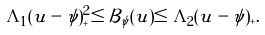Convert formula to latex. <formula><loc_0><loc_0><loc_500><loc_500>\Lambda _ { 1 } ( u - \psi ) _ { + } ^ { 2 } \leq \mathcal { B } _ { \psi } ( u ) \leq \Lambda _ { 2 } ( u - \psi ) _ { + } .</formula> 